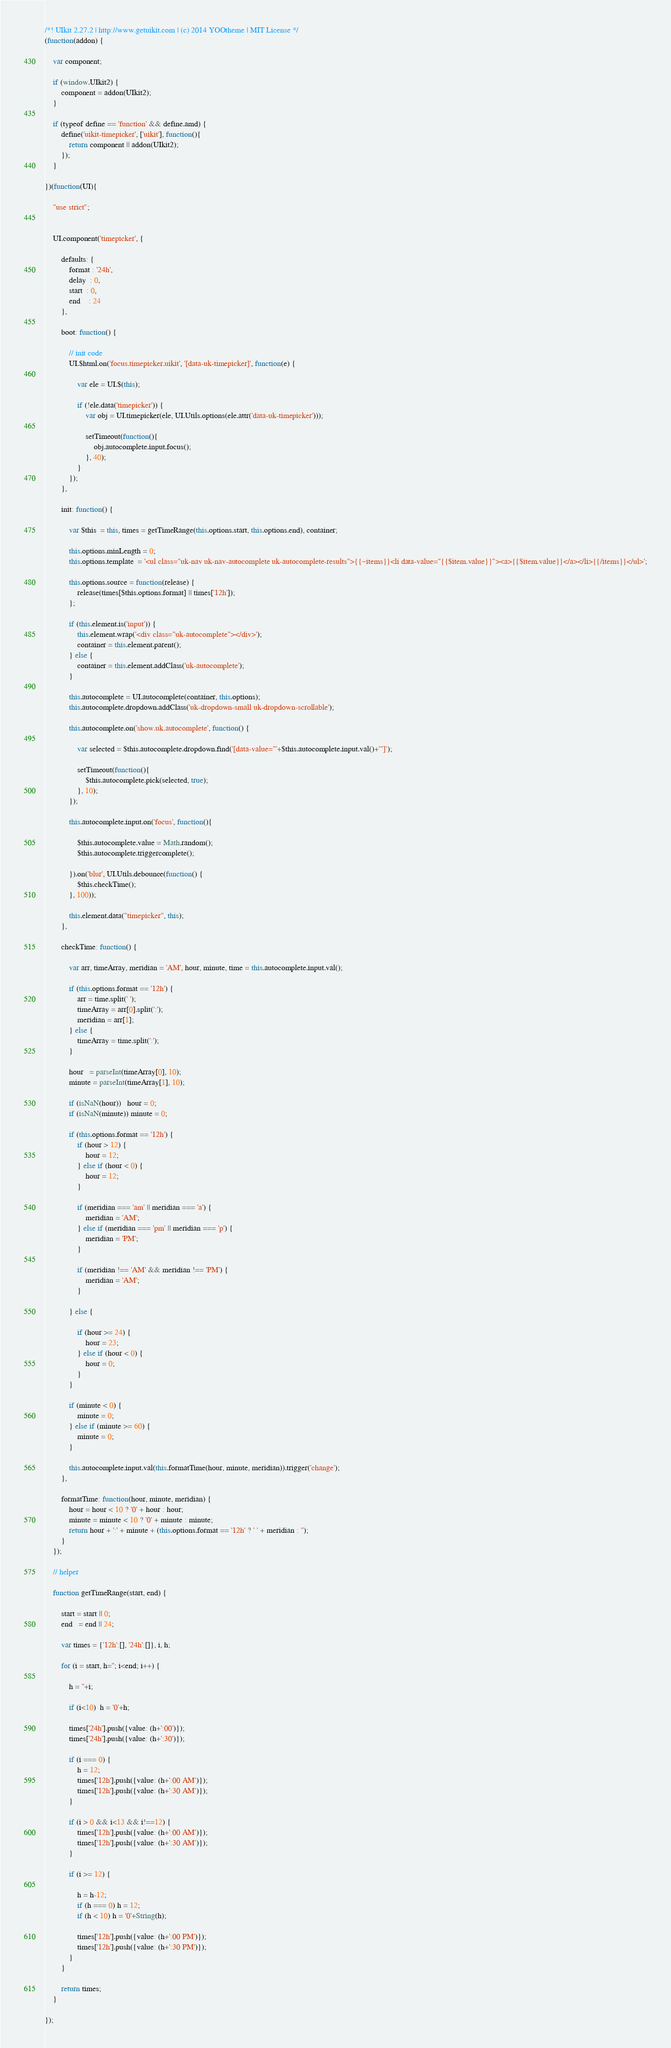<code> <loc_0><loc_0><loc_500><loc_500><_JavaScript_>/*! UIkit 2.27.2 | http://www.getuikit.com | (c) 2014 YOOtheme | MIT License */
(function(addon) {

    var component;

    if (window.UIkit2) {
        component = addon(UIkit2);
    }

    if (typeof define == 'function' && define.amd) {
        define('uikit-timepicker', ['uikit'], function(){
            return component || addon(UIkit2);
        });
    }

})(function(UI){

    "use strict";


    UI.component('timepicker', {

        defaults: {
            format : '24h',
            delay  : 0,
            start  : 0,
            end    : 24
        },

        boot: function() {

            // init code
            UI.$html.on('focus.timepicker.uikit', '[data-uk-timepicker]', function(e) {

                var ele = UI.$(this);

                if (!ele.data('timepicker')) {
                    var obj = UI.timepicker(ele, UI.Utils.options(ele.attr('data-uk-timepicker')));

                    setTimeout(function(){
                        obj.autocomplete.input.focus();
                    }, 40);
                }
            });
        },

        init: function() {

            var $this  = this, times = getTimeRange(this.options.start, this.options.end), container;

            this.options.minLength = 0;
            this.options.template  = '<ul class="uk-nav uk-nav-autocomplete uk-autocomplete-results">{{~items}}<li data-value="{{$item.value}}"><a>{{$item.value}}</a></li>{{/items}}</ul>';

            this.options.source = function(release) {
                release(times[$this.options.format] || times['12h']);
            };

            if (this.element.is('input')) {
                this.element.wrap('<div class="uk-autocomplete"></div>');
                container = this.element.parent();
            } else {
                container = this.element.addClass('uk-autocomplete');
            }

            this.autocomplete = UI.autocomplete(container, this.options);
            this.autocomplete.dropdown.addClass('uk-dropdown-small uk-dropdown-scrollable');

            this.autocomplete.on('show.uk.autocomplete', function() {

                var selected = $this.autocomplete.dropdown.find('[data-value="'+$this.autocomplete.input.val()+'"]');

                setTimeout(function(){
                    $this.autocomplete.pick(selected, true);
                }, 10);
            });

            this.autocomplete.input.on('focus', function(){

                $this.autocomplete.value = Math.random();
                $this.autocomplete.triggercomplete();

            }).on('blur', UI.Utils.debounce(function() {
                $this.checkTime();
            }, 100));

            this.element.data("timepicker", this);
        },

        checkTime: function() {

            var arr, timeArray, meridian = 'AM', hour, minute, time = this.autocomplete.input.val();

            if (this.options.format == '12h') {
                arr = time.split(' ');
                timeArray = arr[0].split(':');
                meridian = arr[1];
            } else {
                timeArray = time.split(':');
            }

            hour   = parseInt(timeArray[0], 10);
            minute = parseInt(timeArray[1], 10);

            if (isNaN(hour))   hour = 0;
            if (isNaN(minute)) minute = 0;

            if (this.options.format == '12h') {
                if (hour > 12) {
                    hour = 12;
                } else if (hour < 0) {
                    hour = 12;
                }

                if (meridian === 'am' || meridian === 'a') {
                    meridian = 'AM';
                } else if (meridian === 'pm' || meridian === 'p') {
                    meridian = 'PM';
                }

                if (meridian !== 'AM' && meridian !== 'PM') {
                    meridian = 'AM';
                }

            } else {

                if (hour >= 24) {
                    hour = 23;
                } else if (hour < 0) {
                    hour = 0;
                }
            }

            if (minute < 0) {
                minute = 0;
            } else if (minute >= 60) {
                minute = 0;
            }

            this.autocomplete.input.val(this.formatTime(hour, minute, meridian)).trigger('change');
        },

        formatTime: function(hour, minute, meridian) {
            hour = hour < 10 ? '0' + hour : hour;
            minute = minute < 10 ? '0' + minute : minute;
            return hour + ':' + minute + (this.options.format == '12h' ? ' ' + meridian : '');
        }
    });

    // helper

    function getTimeRange(start, end) {

        start = start || 0;
        end   = end || 24;

        var times = {'12h':[], '24h':[]}, i, h;

        for (i = start, h=''; i<end; i++) {

            h = ''+i;

            if (i<10)  h = '0'+h;

            times['24h'].push({value: (h+':00')});
            times['24h'].push({value: (h+':30')});

            if (i === 0) {
                h = 12;
                times['12h'].push({value: (h+':00 AM')});
                times['12h'].push({value: (h+':30 AM')});
            }

            if (i > 0 && i<13 && i!==12) {
                times['12h'].push({value: (h+':00 AM')});
                times['12h'].push({value: (h+':30 AM')});
            }

            if (i >= 12) {

                h = h-12;
                if (h === 0) h = 12;
                if (h < 10) h = '0'+String(h);

                times['12h'].push({value: (h+':00 PM')});
                times['12h'].push({value: (h+':30 PM')});
            }
        }

        return times;
    }

});
</code> 